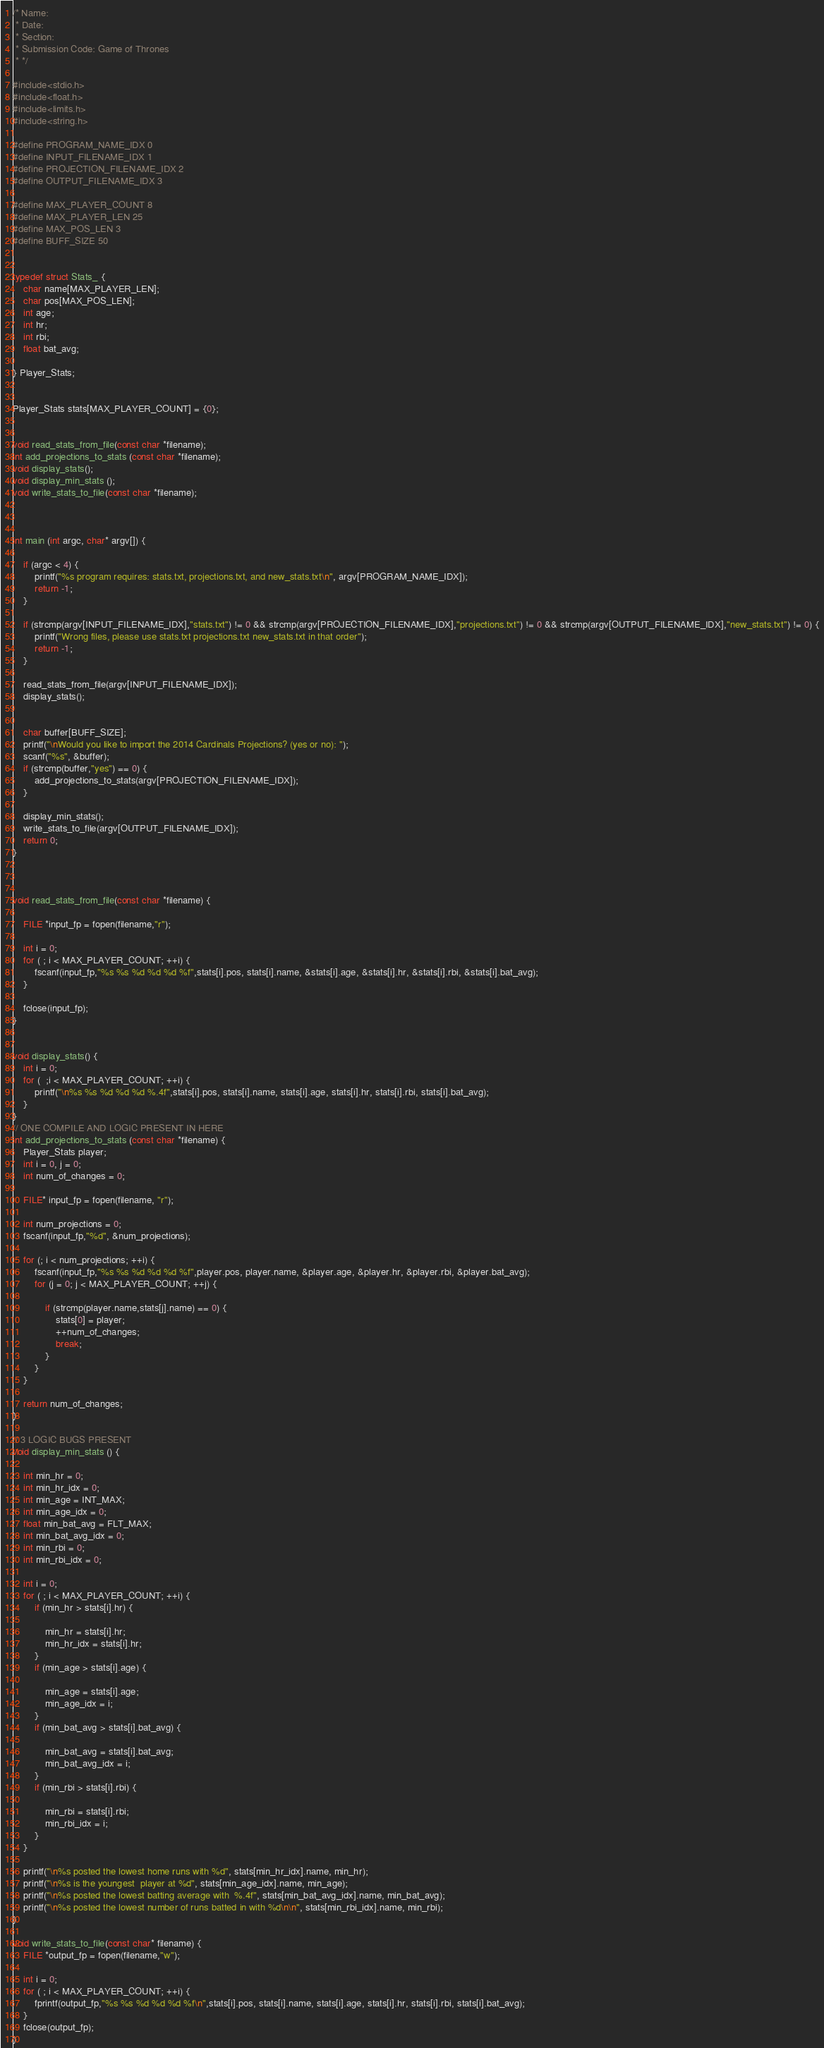<code> <loc_0><loc_0><loc_500><loc_500><_C_>/* Name:
 * Date:
 * Section:
 * Submission Code: Game of Thrones
 * */

#include<stdio.h>
#include<float.h>
#include<limits.h>
#include<string.h>

#define PROGRAM_NAME_IDX 0
#define INPUT_FILENAME_IDX 1
#define PROJECTION_FILENAME_IDX 2
#define OUTPUT_FILENAME_IDX 3

#define MAX_PLAYER_COUNT 8
#define MAX_PLAYER_LEN 25
#define MAX_POS_LEN 3
#define BUFF_SIZE 50


typedef struct Stats_ {
	char name[MAX_PLAYER_LEN];
	char pos[MAX_POS_LEN];
	int age;
	int hr;
	int rbi;
	float bat_avg;

} Player_Stats;


Player_Stats stats[MAX_PLAYER_COUNT] = {0};


void read_stats_from_file(const char *filename);
int add_projections_to_stats (const char *filename);
void display_stats();
void display_min_stats (); 
void write_stats_to_file(const char *filename);



int main (int argc, char* argv[]) {
	
	if (argc < 4) {
		printf("%s program requires: stats.txt, projections.txt, and new_stats.txt\n", argv[PROGRAM_NAME_IDX]);
		return -1;
	}
	
	if (strcmp(argv[INPUT_FILENAME_IDX],"stats.txt") != 0 && strcmp(argv[PROJECTION_FILENAME_IDX],"projections.txt") != 0 && strcmp(argv[OUTPUT_FILENAME_IDX],"new_stats.txt") != 0) {
		printf("Wrong files, please use stats.txt projections.txt new_stats.txt in that order");
		return -1;
	}
	
	read_stats_from_file(argv[INPUT_FILENAME_IDX]);
	display_stats();
	
	
	char buffer[BUFF_SIZE];
	printf("\nWould you like to import the 2014 Cardinals Projections? (yes or no): ");
	scanf("%s", &buffer);
	if (strcmp(buffer,"yes") == 0) {
		add_projections_to_stats(argv[PROJECTION_FILENAME_IDX]);
	}

	display_min_stats();
	write_stats_to_file(argv[OUTPUT_FILENAME_IDX]);
	return 0;
}



void read_stats_from_file(const char *filename) {
	
	FILE *input_fp = fopen(filename,"r");
	
	int i = 0;
	for ( ; i < MAX_PLAYER_COUNT; ++i) {
		fscanf(input_fp,"%s %s %d %d %d %f",stats[i].pos, stats[i].name, &stats[i].age, &stats[i].hr, &stats[i].rbi, &stats[i].bat_avg);
	}

	fclose(input_fp);
}


void display_stats() {
	int i = 0;
	for (  ;i < MAX_PLAYER_COUNT; ++i) {
		printf("\n%s %s %d %d %d %.4f",stats[i].pos, stats[i].name, stats[i].age, stats[i].hr, stats[i].rbi, stats[i].bat_avg);
	}
}
// ONE COMPILE AND LOGIC PRESENT IN HERE
int add_projections_to_stats (const char *filename) {	
	Player_Stats player;
	int i = 0, j = 0;
	int num_of_changes = 0;

	FILE* input_fp = fopen(filename, "r");
	
	int num_projections = 0;
	fscanf(input_fp,"%d", &num_projections);

	for (; i < num_projections; ++i) {
		fscanf(input_fp,"%s %s %d %d %d %f",player.pos, player.name, &player.age, &player.hr, &player.rbi, &player.bat_avg);
		for (j = 0; j < MAX_PLAYER_COUNT; ++j) {
			
			if (strcmp(player.name,stats[j].name) == 0) {
				stats[0] = player;
				++num_of_changes;
				break;
			}
		}
	}

	return num_of_changes;
}

// 3 LOGIC BUGS PRESENT
void display_min_stats () {
	
	int min_hr = 0;
	int min_hr_idx = 0;
	int min_age = INT_MAX;
	int min_age_idx = 0;
	float min_bat_avg = FLT_MAX;
	int min_bat_avg_idx = 0;
	int min_rbi = 0;
	int min_rbi_idx = 0;

	int i = 0;
	for ( ; i < MAX_PLAYER_COUNT; ++i) {
		if (min_hr > stats[i].hr) {
			
			min_hr = stats[i].hr;
			min_hr_idx = stats[i].hr;
		}
		if (min_age > stats[i].age) {
			
			min_age = stats[i].age;
			min_age_idx = i;
		}
		if (min_bat_avg > stats[i].bat_avg) {
			
			min_bat_avg = stats[i].bat_avg;
			min_bat_avg_idx = i;
		}
		if (min_rbi > stats[i].rbi) {
			
			min_rbi = stats[i].rbi;
			min_rbi_idx = i;
		}
	}

	printf("\n%s posted the lowest home runs with %d", stats[min_hr_idx].name, min_hr);
	printf("\n%s is the youngest  player at %d", stats[min_age_idx].name, min_age);
	printf("\n%s posted the lowest batting average with  %.4f", stats[min_bat_avg_idx].name, min_bat_avg);
	printf("\n%s posted the lowest number of runs batted in with %d\n\n", stats[min_rbi_idx].name, min_rbi);
}

void write_stats_to_file(const char* filename) {
	FILE *output_fp = fopen(filename,"w");
	
	int i = 0;
	for ( ; i < MAX_PLAYER_COUNT; ++i) {
		fprintf(output_fp,"%s %s %d %d %d %f\n",stats[i].pos, stats[i].name, stats[i].age, stats[i].hr, stats[i].rbi, stats[i].bat_avg);
	}
	fclose(output_fp);
}
</code> 